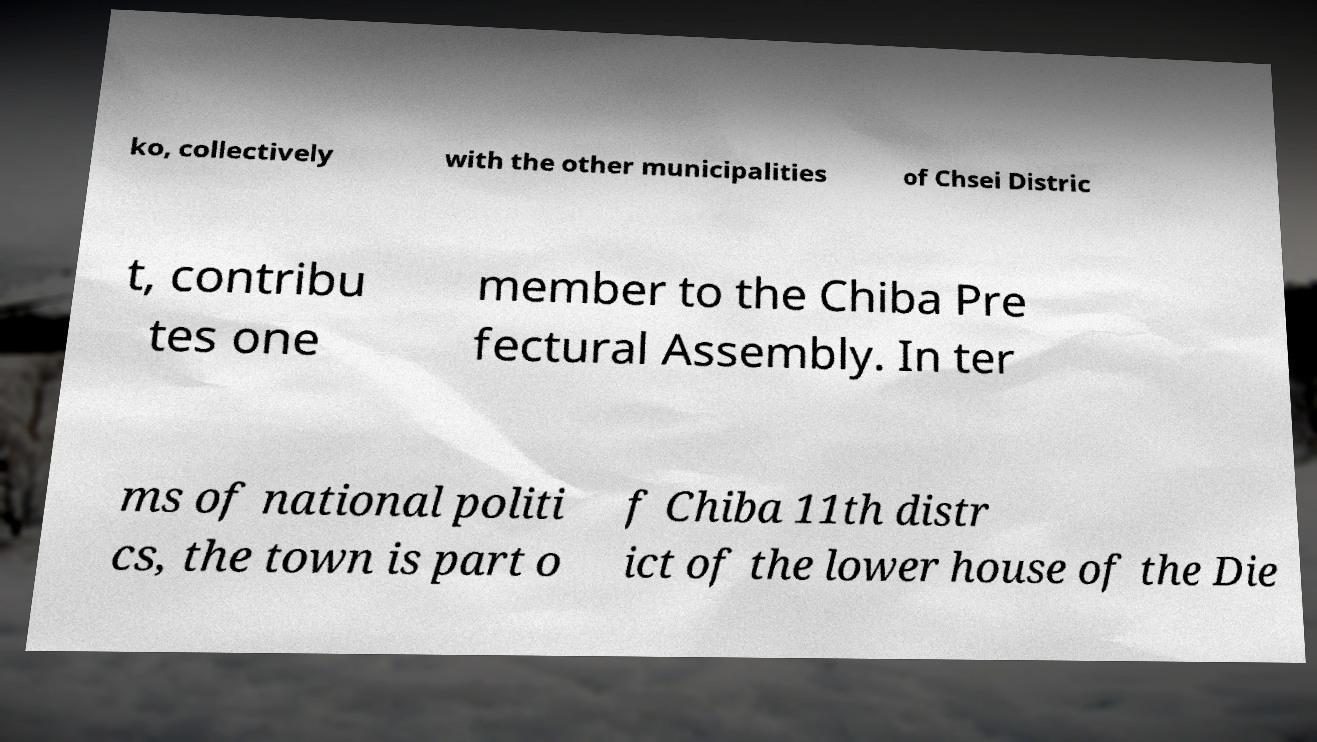Can you read and provide the text displayed in the image?This photo seems to have some interesting text. Can you extract and type it out for me? ko, collectively with the other municipalities of Chsei Distric t, contribu tes one member to the Chiba Pre fectural Assembly. In ter ms of national politi cs, the town is part o f Chiba 11th distr ict of the lower house of the Die 